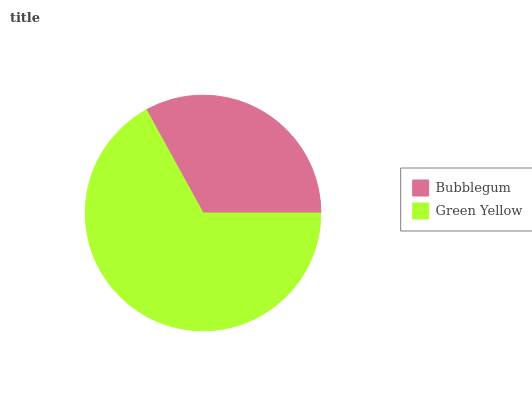Is Bubblegum the minimum?
Answer yes or no. Yes. Is Green Yellow the maximum?
Answer yes or no. Yes. Is Green Yellow the minimum?
Answer yes or no. No. Is Green Yellow greater than Bubblegum?
Answer yes or no. Yes. Is Bubblegum less than Green Yellow?
Answer yes or no. Yes. Is Bubblegum greater than Green Yellow?
Answer yes or no. No. Is Green Yellow less than Bubblegum?
Answer yes or no. No. Is Green Yellow the high median?
Answer yes or no. Yes. Is Bubblegum the low median?
Answer yes or no. Yes. Is Bubblegum the high median?
Answer yes or no. No. Is Green Yellow the low median?
Answer yes or no. No. 